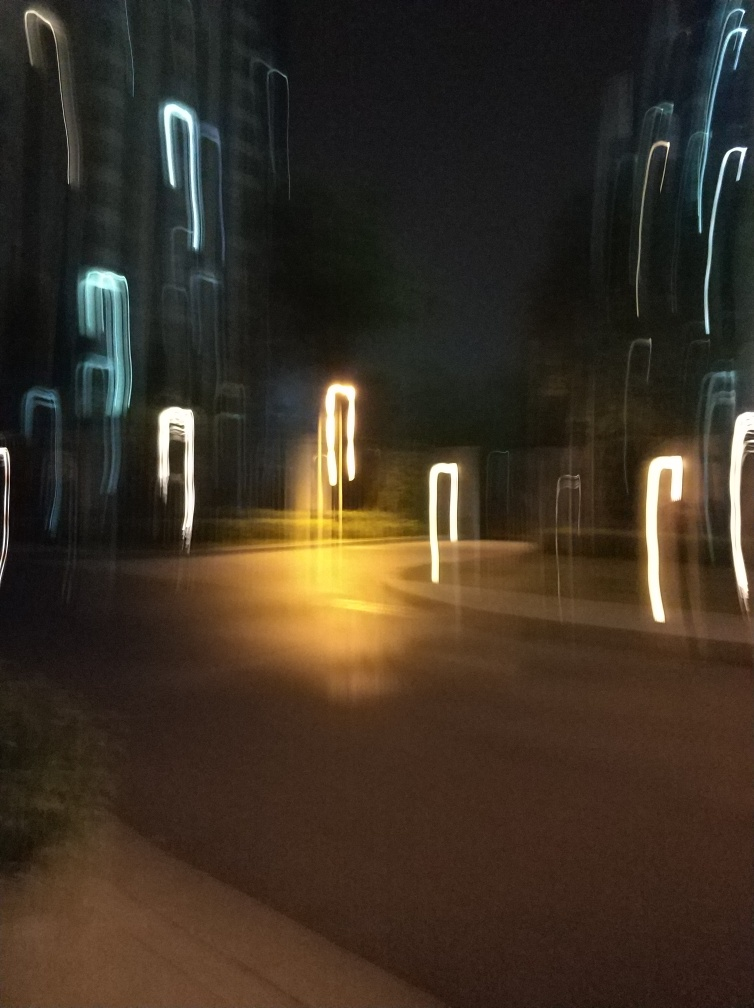Why are the colors not clear in this image? The colors in this image are not clear due to motion blur, which occurs when the camera is moved during the exposure. This can create a sense of movement and abstract shapes with light, resulting in less definition of the original colors and subjects. The effect can be used artistically to convey a sense of speed or the passage of time. 